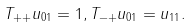<formula> <loc_0><loc_0><loc_500><loc_500>T _ { + + } u _ { 0 1 } = 1 , T _ { - + } u _ { 0 1 } = u _ { 1 1 } .</formula> 